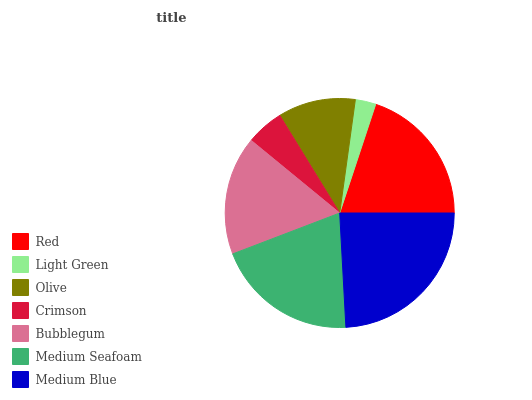Is Light Green the minimum?
Answer yes or no. Yes. Is Medium Blue the maximum?
Answer yes or no. Yes. Is Olive the minimum?
Answer yes or no. No. Is Olive the maximum?
Answer yes or no. No. Is Olive greater than Light Green?
Answer yes or no. Yes. Is Light Green less than Olive?
Answer yes or no. Yes. Is Light Green greater than Olive?
Answer yes or no. No. Is Olive less than Light Green?
Answer yes or no. No. Is Bubblegum the high median?
Answer yes or no. Yes. Is Bubblegum the low median?
Answer yes or no. Yes. Is Red the high median?
Answer yes or no. No. Is Crimson the low median?
Answer yes or no. No. 